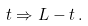Convert formula to latex. <formula><loc_0><loc_0><loc_500><loc_500>t \Rightarrow L - t \, .</formula> 